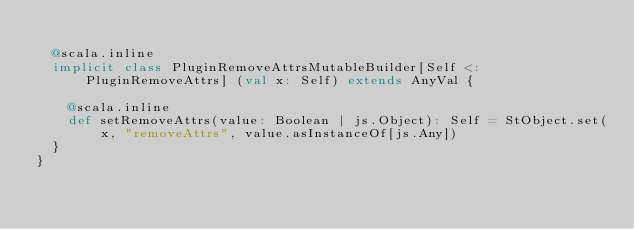<code> <loc_0><loc_0><loc_500><loc_500><_Scala_>  
  @scala.inline
  implicit class PluginRemoveAttrsMutableBuilder[Self <: PluginRemoveAttrs] (val x: Self) extends AnyVal {
    
    @scala.inline
    def setRemoveAttrs(value: Boolean | js.Object): Self = StObject.set(x, "removeAttrs", value.asInstanceOf[js.Any])
  }
}
</code> 